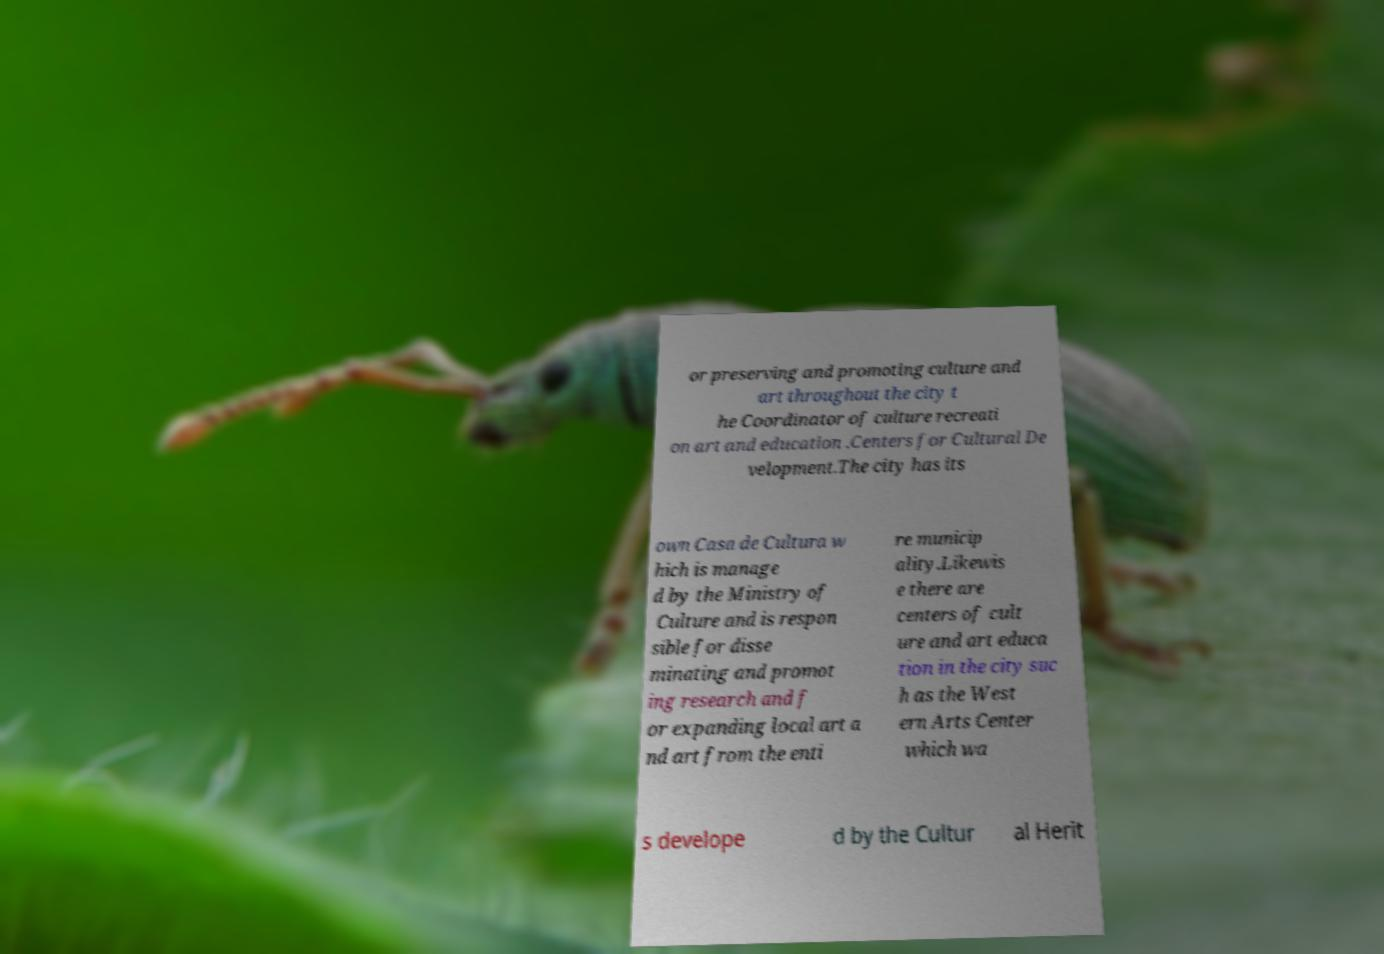What messages or text are displayed in this image? I need them in a readable, typed format. or preserving and promoting culture and art throughout the city t he Coordinator of culture recreati on art and education .Centers for Cultural De velopment.The city has its own Casa de Cultura w hich is manage d by the Ministry of Culture and is respon sible for disse minating and promot ing research and f or expanding local art a nd art from the enti re municip ality.Likewis e there are centers of cult ure and art educa tion in the city suc h as the West ern Arts Center which wa s develope d by the Cultur al Herit 